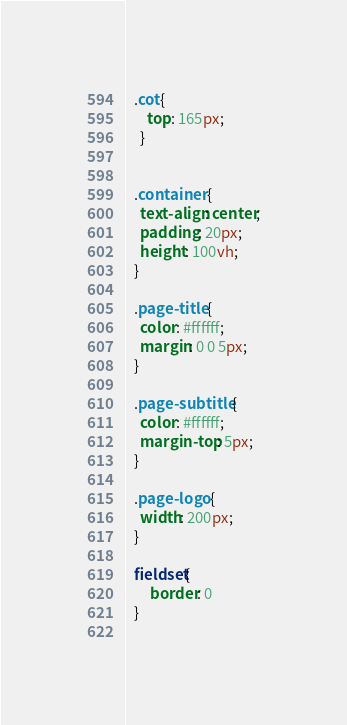Convert code to text. <code><loc_0><loc_0><loc_500><loc_500><_CSS_>  .cot{
      top: 165px;
    }
  
  
  .container {
    text-align: center;
    padding: 20px;
    height: 100vh;
  }
  
  .page-title {
    color: #ffffff;
    margin: 0 0 5px;
  }
  
  .page-subtitle {
    color: #ffffff;
    margin-top: 5px;
  }
  
  .page-logo {
    width: 200px;
  }
  
  fieldset{
       border: 0
  }
  </code> 